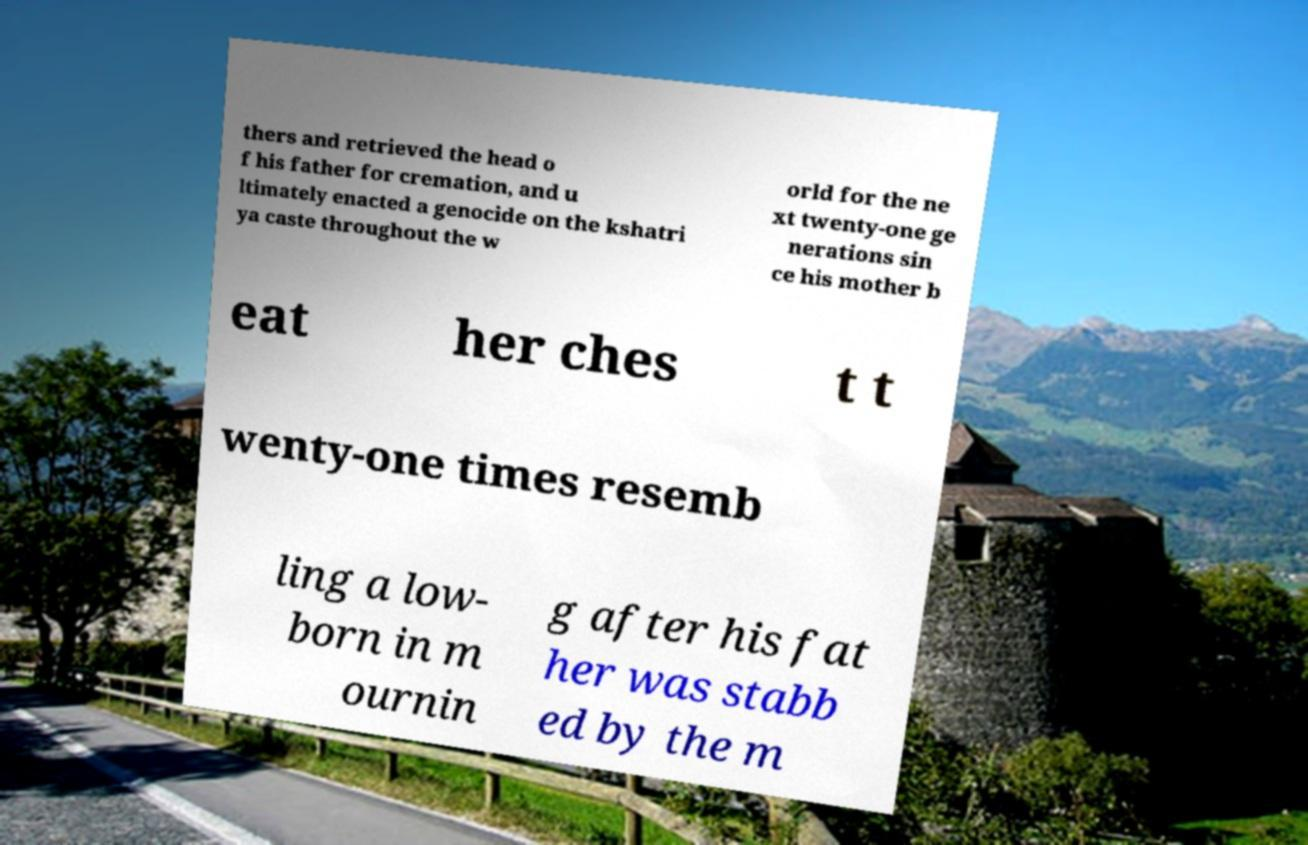Could you extract and type out the text from this image? thers and retrieved the head o f his father for cremation, and u ltimately enacted a genocide on the kshatri ya caste throughout the w orld for the ne xt twenty-one ge nerations sin ce his mother b eat her ches t t wenty-one times resemb ling a low- born in m ournin g after his fat her was stabb ed by the m 